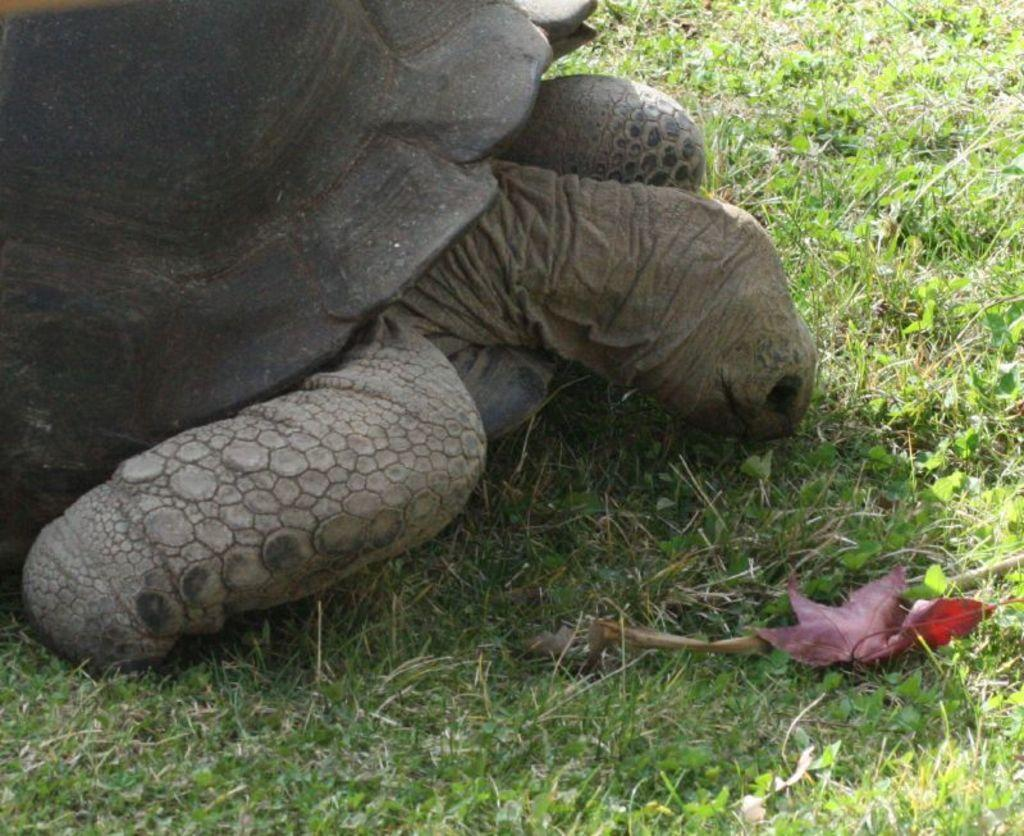What type of animal is in the image? There is a tortoise in the image. What is the tortoise's location in the image? The tortoise is on the surface of the grass. Can you see any friends of the tortoise in the image? There is no mention of any friends of the tortoise in the image. Are there any fairies interacting with the tortoise in the image? There is no mention of any fairies in the image. Is the tortoise wearing a mitten in the image? There is no mention of any clothing or accessories on the tortoise in the image. 